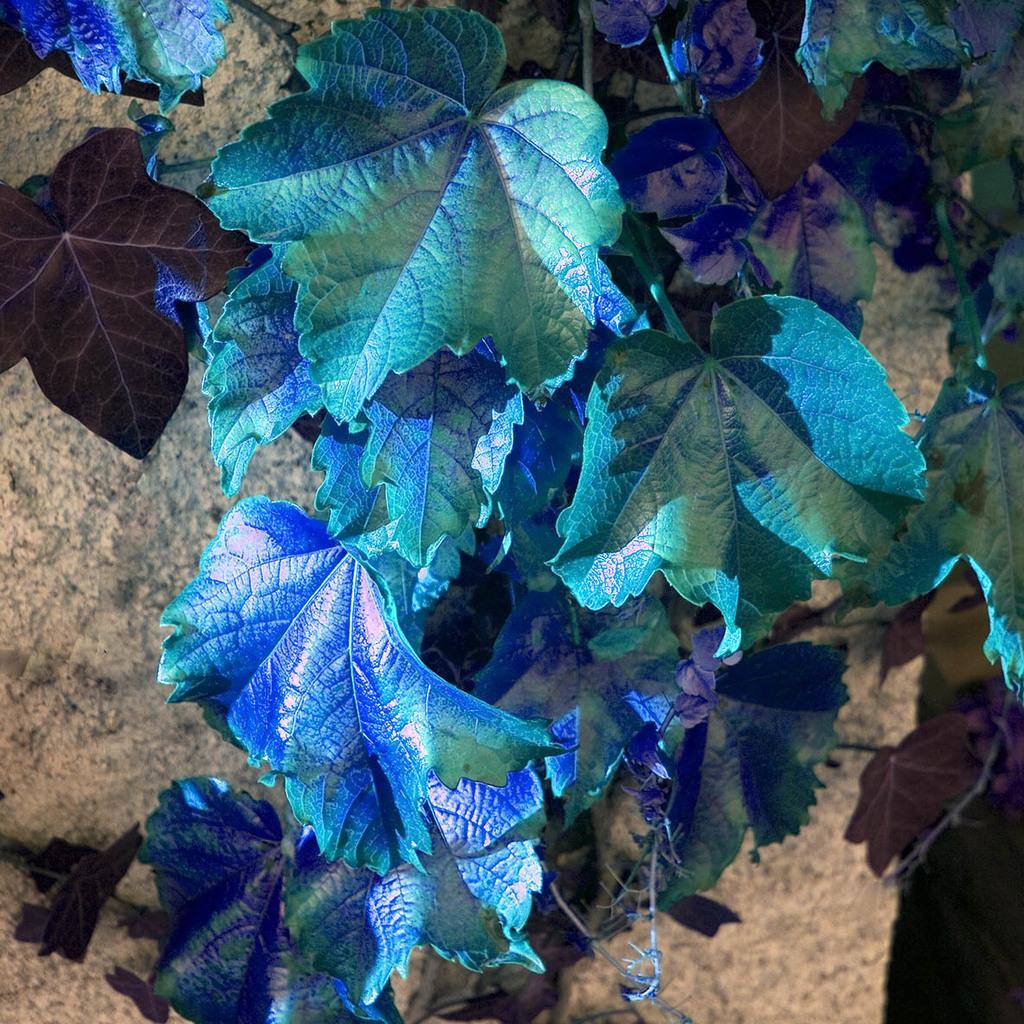Could you give a brief overview of what you see in this image? In this image we can see some blue and green color leaves with stems on the ground. 